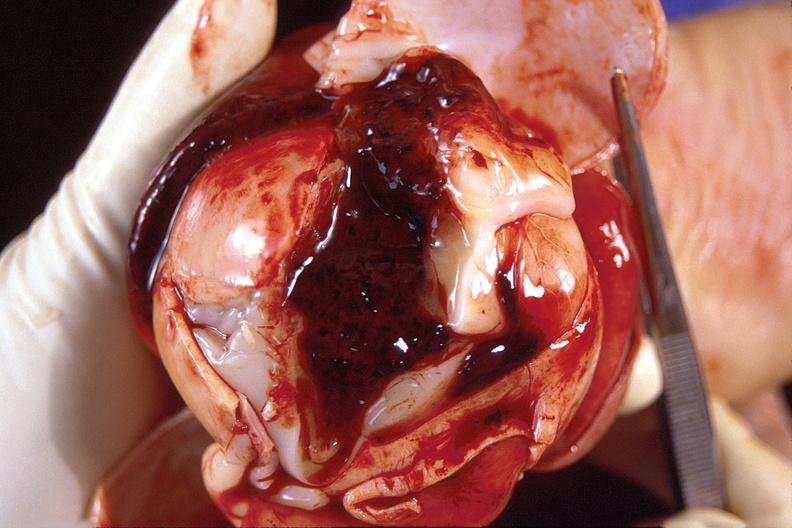s nervous present?
Answer the question using a single word or phrase. Yes 